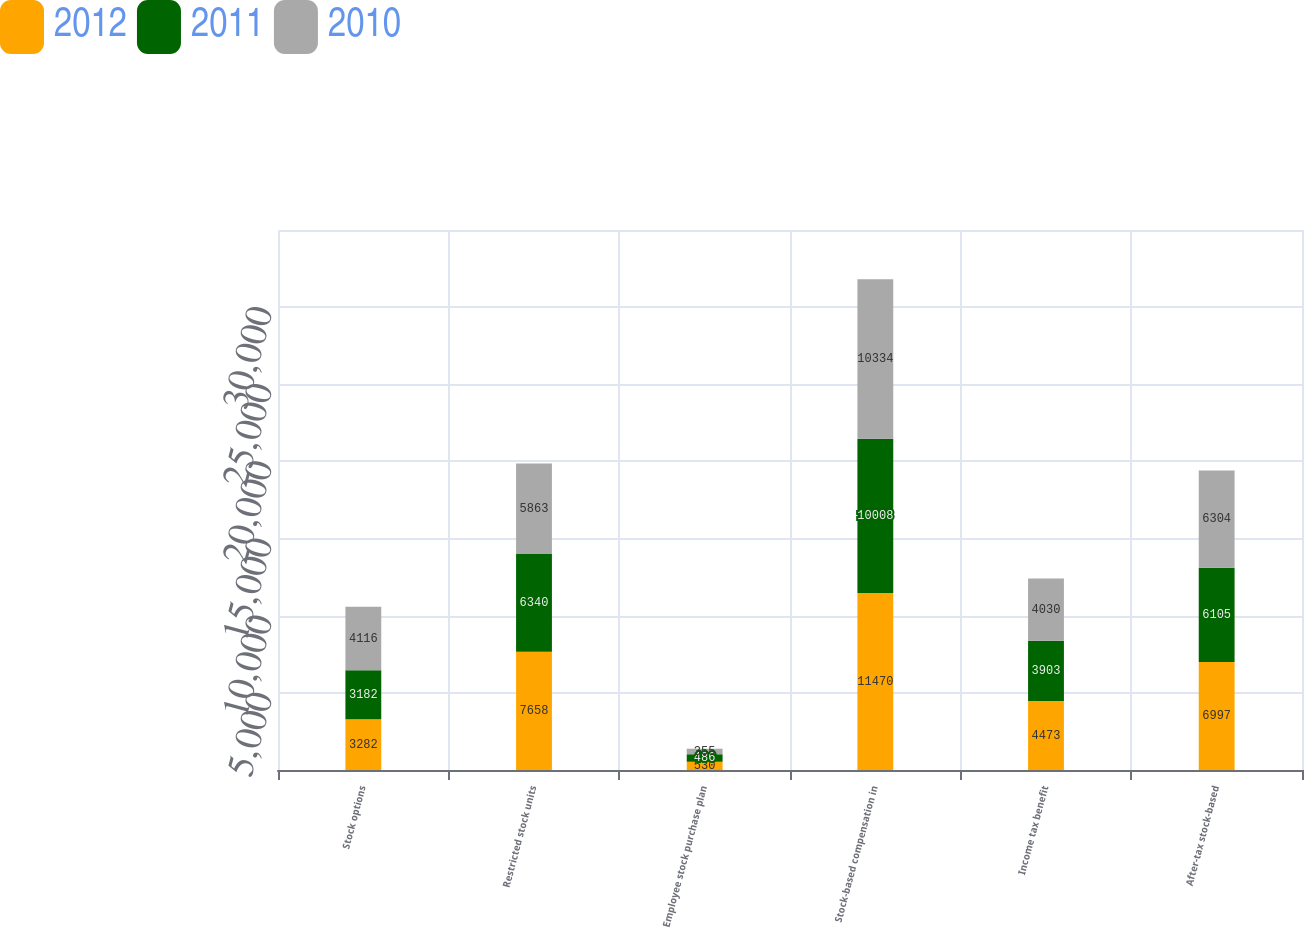Convert chart to OTSL. <chart><loc_0><loc_0><loc_500><loc_500><stacked_bar_chart><ecel><fcel>Stock options<fcel>Restricted stock units<fcel>Employee stock purchase plan<fcel>Stock-based compensation in<fcel>Income tax benefit<fcel>After-tax stock-based<nl><fcel>2012<fcel>3282<fcel>7658<fcel>530<fcel>11470<fcel>4473<fcel>6997<nl><fcel>2011<fcel>3182<fcel>6340<fcel>486<fcel>10008<fcel>3903<fcel>6105<nl><fcel>2010<fcel>4116<fcel>5863<fcel>355<fcel>10334<fcel>4030<fcel>6304<nl></chart> 